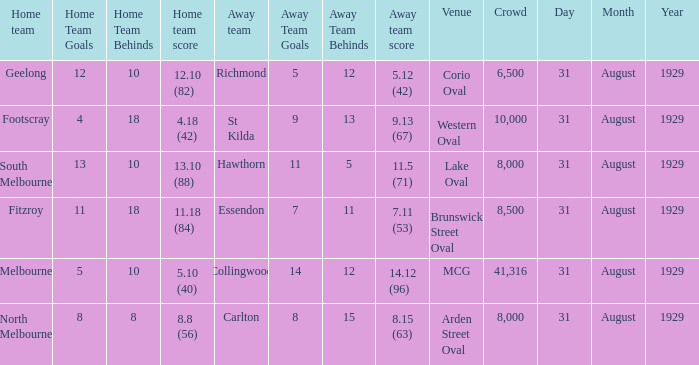What date was the game when the away team was carlton? 31 August 1929. 